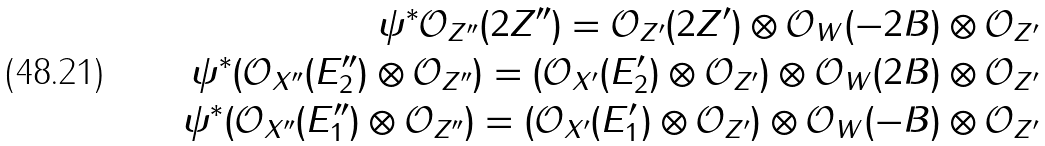Convert formula to latex. <formula><loc_0><loc_0><loc_500><loc_500>\psi ^ { \ast } \mathcal { O } _ { Z ^ { \prime \prime } } ( 2 Z ^ { \prime \prime } ) = \mathcal { O } _ { Z ^ { \prime } } ( 2 Z ^ { \prime } ) \otimes \mathcal { O } _ { W } ( - 2 B ) \otimes \mathcal { O } _ { Z ^ { \prime } } \\ \psi ^ { \ast } ( \mathcal { O } _ { X ^ { \prime \prime } } ( E _ { 2 } ^ { \prime \prime } ) \otimes \mathcal { O } _ { Z ^ { \prime \prime } } ) = ( \mathcal { O } _ { X ^ { \prime } } ( E _ { 2 } ^ { \prime } ) \otimes \mathcal { O } _ { Z ^ { \prime } } ) \otimes \mathcal { O } _ { W } ( 2 B ) \otimes \mathcal { O } _ { Z ^ { \prime } } \\ \psi ^ { \ast } ( \mathcal { O } _ { X ^ { \prime \prime } } ( E _ { 1 } ^ { \prime \prime } ) \otimes \mathcal { O } _ { Z ^ { \prime \prime } } ) = ( \mathcal { O } _ { X ^ { \prime } } ( E _ { 1 } ^ { \prime } ) \otimes \mathcal { O } _ { Z ^ { \prime } } ) \otimes \mathcal { O } _ { W } ( - B ) \otimes \mathcal { O } _ { Z ^ { \prime } } \\</formula> 